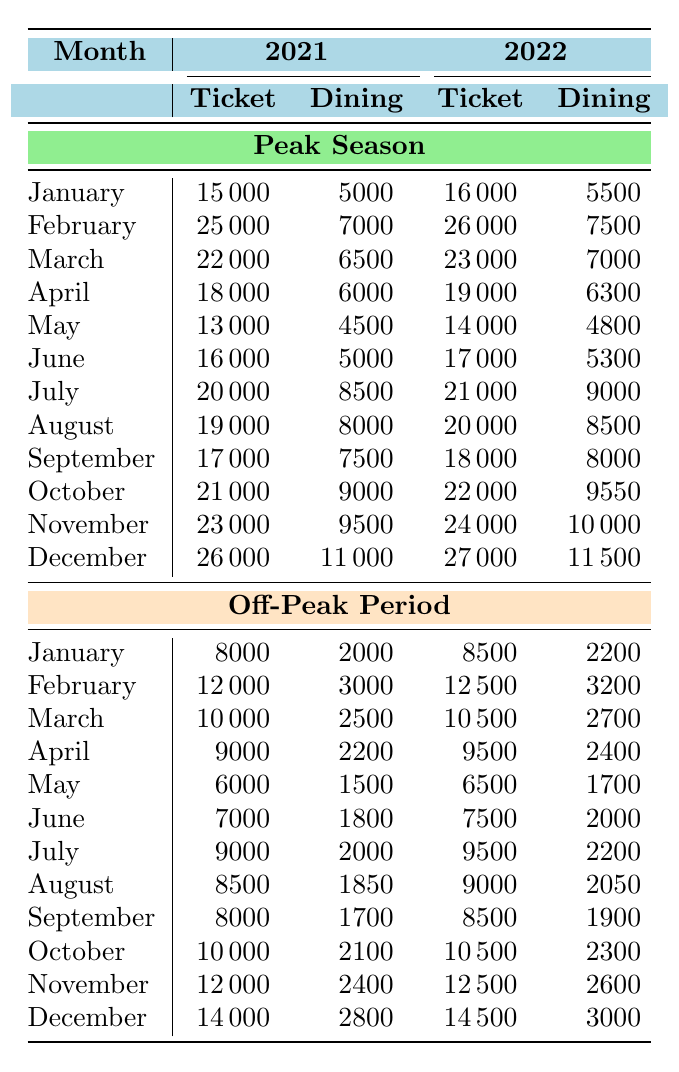What were the total Ticket Sales in December 2021 during Peak Season? The ticket sales for December 2021 in Peak Season was 26000.
Answer: 26000 How much did Dining Package Sales increase from January 2021 to January 2022 during Peak Season? In January 2021, Dining Package Sales were 5000, and in January 2022, they were 5500. The increase is 5500 - 5000 = 500.
Answer: 500 Which month had the highest Dining Package Sales in 2022? Observing the Peak Season and Off-Peak Periods in 2022, December had the highest Dining Package Sales with 11500.
Answer: 11500 Did the total Ticket Sales during Off-Peak Periods increase or decrease from 2021 to 2022? Summing the Ticket Sales for all months during Off-Peak for 2021 gives 108800 (sum of individual months), and for 2022, it totals to 110800. Since 110800 > 108800, the total increased.
Answer: Increased What is the average Dining Package Sales during Peak Season for the month of May across both years? For Peak Season in May, Dining Package Sales were 4500 in 2021 and 4800 in 2022. The average is (4500 + 4800) / 2 = 4650.
Answer: 4650 Which month in 2021 had a higher Ticket Sales than the total Dining Package Sales during the same month? For January 2021, Ticket Sales were 15000 and Dining Package Sales were 5000 (15000 > 5000). This pattern continues for every month except for May where 13000 > 4500, and 21000 > 9000 in October as well.
Answer: January, February, March, April, June, July, August, September, October, November, December What was the total Ticket Sales and Dining Package Sales combined in August 2021? In August 2021, Ticket Sales were 19000, and Dining Package Sales were 8000. The combined total is 19000 + 8000 = 27000.
Answer: 27000 Was the Dining Package Sales higher during Peak Season or Off-Peak Period in December 2022? For December 2022, Dining Package Sales during Peak Season were 11500, and during Off-Peak Period, it was 3000. Since 11500 > 3000, Peak Season had higher sales.
Answer: Yes How much did the total Dining Package Sales drop from November 2021 to November 2022 during Peak Season? In November 2021, Dining Package Sales were 9500 and in November 2022, they were 10000. Thus, the change is 10000 - 9500 = 500, which indicates an increase instead of a drop.
Answer: Increased by 500 